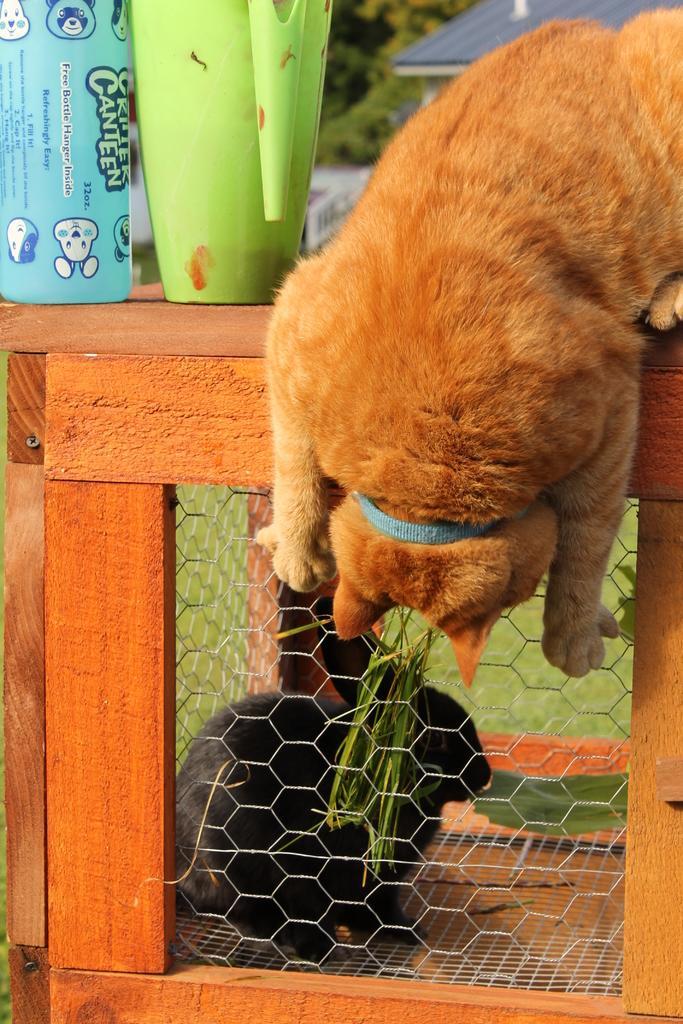Describe this image in one or two sentences. We can see cat and glasses on the wooden surface. We can see rabbit inside a mesh box,through this mess we can see grass. Background we can see roof top. 